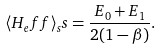<formula> <loc_0><loc_0><loc_500><loc_500>\langle { H } _ { e } f f \rangle _ { s } s = \frac { E _ { 0 } + E _ { 1 } } { 2 ( 1 - \beta ) } .</formula> 